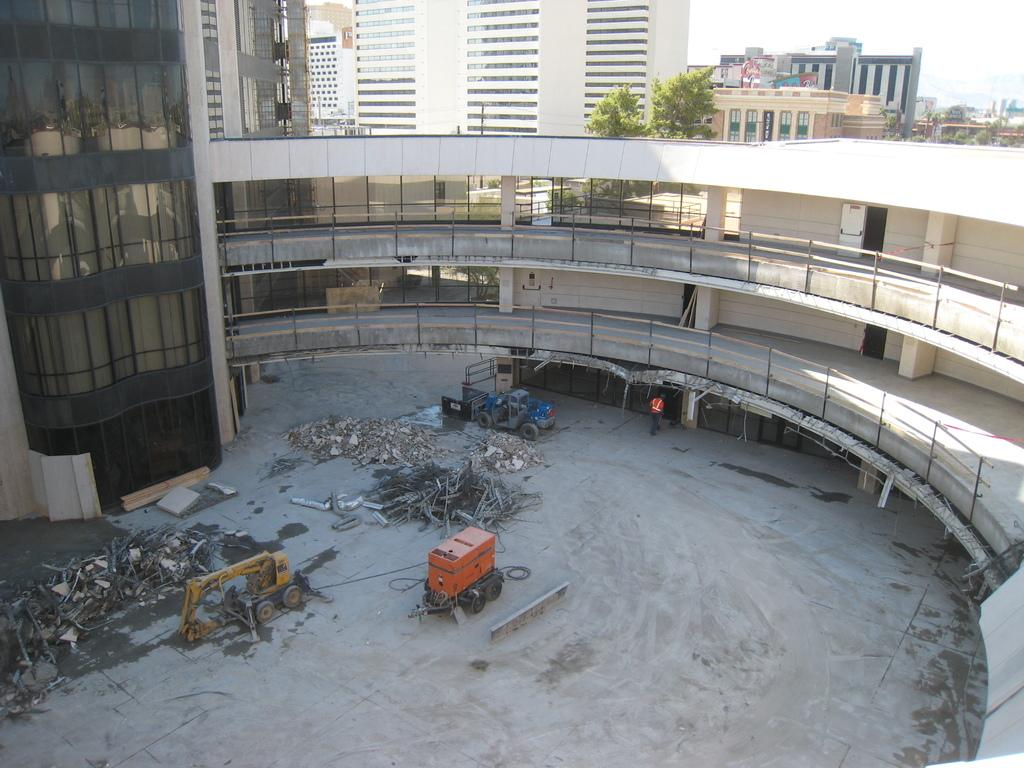What type of machinery is present on the ground in the image? There is a crane on the ground in the image. What can be seen in the distance behind the crane? There are buildings visible in the background of the image. Are there any people present in the image? Yes, there is a person in the image. What type of meeting is taking place between the mother and the cars in the image? There is no mother or cars present in the image, so no such meeting can be observed. 